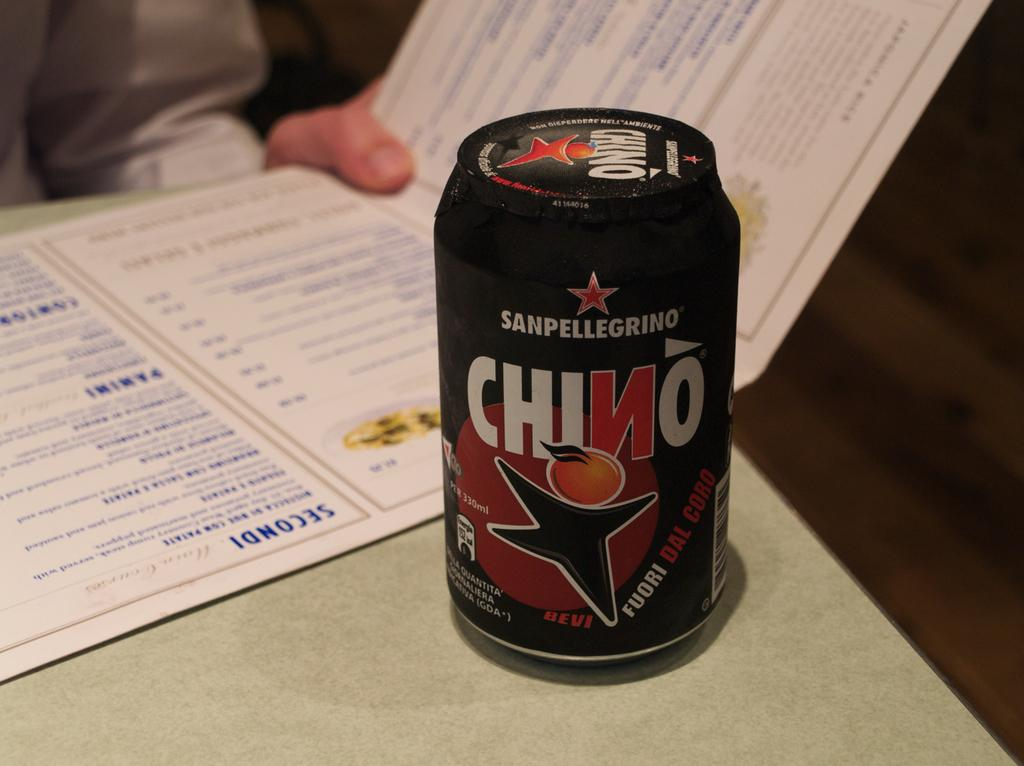<image>
Share a concise interpretation of the image provided. A softdrink names SANPELLEGRINO sits on top of sa table. 